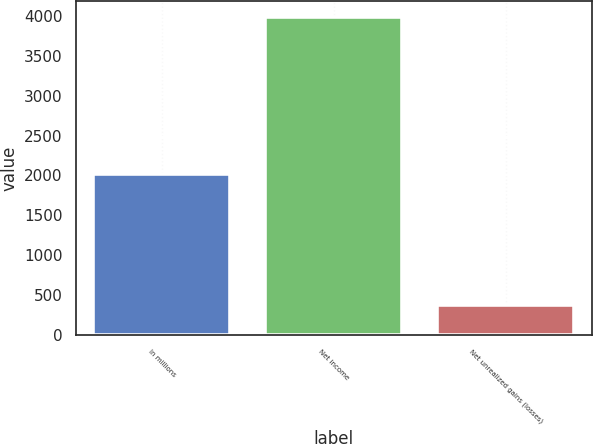<chart> <loc_0><loc_0><loc_500><loc_500><bar_chart><fcel>In millions<fcel>Net income<fcel>Net unrealized gains (losses)<nl><fcel>2016<fcel>3985<fcel>369<nl></chart> 